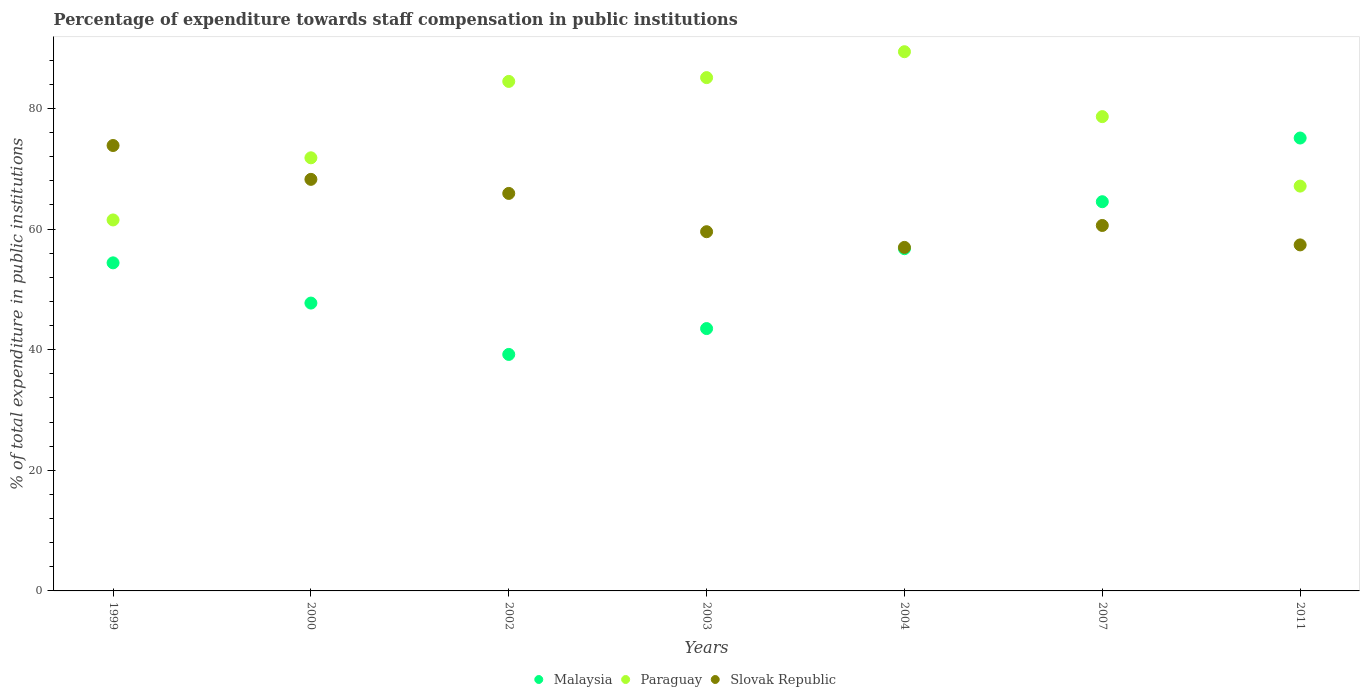How many different coloured dotlines are there?
Keep it short and to the point. 3. What is the percentage of expenditure towards staff compensation in Slovak Republic in 2004?
Ensure brevity in your answer.  56.97. Across all years, what is the maximum percentage of expenditure towards staff compensation in Malaysia?
Offer a very short reply. 75.1. Across all years, what is the minimum percentage of expenditure towards staff compensation in Slovak Republic?
Offer a very short reply. 56.97. In which year was the percentage of expenditure towards staff compensation in Slovak Republic maximum?
Give a very brief answer. 1999. What is the total percentage of expenditure towards staff compensation in Malaysia in the graph?
Provide a short and direct response. 381.25. What is the difference between the percentage of expenditure towards staff compensation in Malaysia in 2000 and that in 2007?
Your response must be concise. -16.81. What is the difference between the percentage of expenditure towards staff compensation in Paraguay in 2002 and the percentage of expenditure towards staff compensation in Malaysia in 2000?
Offer a terse response. 36.76. What is the average percentage of expenditure towards staff compensation in Paraguay per year?
Keep it short and to the point. 76.88. In the year 2007, what is the difference between the percentage of expenditure towards staff compensation in Slovak Republic and percentage of expenditure towards staff compensation in Paraguay?
Your answer should be compact. -18.05. In how many years, is the percentage of expenditure towards staff compensation in Malaysia greater than 12 %?
Ensure brevity in your answer.  7. What is the ratio of the percentage of expenditure towards staff compensation in Slovak Republic in 2000 to that in 2007?
Ensure brevity in your answer.  1.13. Is the percentage of expenditure towards staff compensation in Malaysia in 2000 less than that in 2003?
Make the answer very short. No. What is the difference between the highest and the second highest percentage of expenditure towards staff compensation in Malaysia?
Your response must be concise. 10.56. What is the difference between the highest and the lowest percentage of expenditure towards staff compensation in Slovak Republic?
Provide a succinct answer. 16.89. In how many years, is the percentage of expenditure towards staff compensation in Paraguay greater than the average percentage of expenditure towards staff compensation in Paraguay taken over all years?
Give a very brief answer. 4. Is the sum of the percentage of expenditure towards staff compensation in Malaysia in 2000 and 2002 greater than the maximum percentage of expenditure towards staff compensation in Slovak Republic across all years?
Ensure brevity in your answer.  Yes. Is the percentage of expenditure towards staff compensation in Slovak Republic strictly greater than the percentage of expenditure towards staff compensation in Paraguay over the years?
Keep it short and to the point. No. Is the percentage of expenditure towards staff compensation in Malaysia strictly less than the percentage of expenditure towards staff compensation in Paraguay over the years?
Keep it short and to the point. No. How many dotlines are there?
Your answer should be compact. 3. Are the values on the major ticks of Y-axis written in scientific E-notation?
Your answer should be compact. No. Where does the legend appear in the graph?
Ensure brevity in your answer.  Bottom center. How are the legend labels stacked?
Offer a terse response. Horizontal. What is the title of the graph?
Your answer should be compact. Percentage of expenditure towards staff compensation in public institutions. What is the label or title of the X-axis?
Your answer should be compact. Years. What is the label or title of the Y-axis?
Your response must be concise. % of total expenditure in public institutions. What is the % of total expenditure in public institutions of Malaysia in 1999?
Provide a succinct answer. 54.4. What is the % of total expenditure in public institutions in Paraguay in 1999?
Provide a short and direct response. 61.52. What is the % of total expenditure in public institutions of Slovak Republic in 1999?
Make the answer very short. 73.86. What is the % of total expenditure in public institutions in Malaysia in 2000?
Give a very brief answer. 47.73. What is the % of total expenditure in public institutions of Paraguay in 2000?
Give a very brief answer. 71.82. What is the % of total expenditure in public institutions of Slovak Republic in 2000?
Provide a succinct answer. 68.25. What is the % of total expenditure in public institutions in Malaysia in 2002?
Provide a short and direct response. 39.22. What is the % of total expenditure in public institutions in Paraguay in 2002?
Offer a very short reply. 84.49. What is the % of total expenditure in public institutions in Slovak Republic in 2002?
Give a very brief answer. 65.92. What is the % of total expenditure in public institutions in Malaysia in 2003?
Keep it short and to the point. 43.5. What is the % of total expenditure in public institutions of Paraguay in 2003?
Your answer should be very brief. 85.12. What is the % of total expenditure in public institutions in Slovak Republic in 2003?
Your response must be concise. 59.57. What is the % of total expenditure in public institutions of Malaysia in 2004?
Provide a succinct answer. 56.75. What is the % of total expenditure in public institutions in Paraguay in 2004?
Your answer should be very brief. 89.41. What is the % of total expenditure in public institutions of Slovak Republic in 2004?
Provide a succinct answer. 56.97. What is the % of total expenditure in public institutions in Malaysia in 2007?
Offer a very short reply. 64.54. What is the % of total expenditure in public institutions in Paraguay in 2007?
Give a very brief answer. 78.65. What is the % of total expenditure in public institutions of Slovak Republic in 2007?
Your response must be concise. 60.6. What is the % of total expenditure in public institutions in Malaysia in 2011?
Your answer should be very brief. 75.1. What is the % of total expenditure in public institutions in Paraguay in 2011?
Your response must be concise. 67.13. What is the % of total expenditure in public institutions of Slovak Republic in 2011?
Give a very brief answer. 57.38. Across all years, what is the maximum % of total expenditure in public institutions in Malaysia?
Offer a very short reply. 75.1. Across all years, what is the maximum % of total expenditure in public institutions in Paraguay?
Offer a terse response. 89.41. Across all years, what is the maximum % of total expenditure in public institutions of Slovak Republic?
Make the answer very short. 73.86. Across all years, what is the minimum % of total expenditure in public institutions in Malaysia?
Your answer should be compact. 39.22. Across all years, what is the minimum % of total expenditure in public institutions in Paraguay?
Offer a very short reply. 61.52. Across all years, what is the minimum % of total expenditure in public institutions in Slovak Republic?
Keep it short and to the point. 56.97. What is the total % of total expenditure in public institutions in Malaysia in the graph?
Your answer should be very brief. 381.25. What is the total % of total expenditure in public institutions in Paraguay in the graph?
Give a very brief answer. 538.14. What is the total % of total expenditure in public institutions of Slovak Republic in the graph?
Provide a succinct answer. 442.54. What is the difference between the % of total expenditure in public institutions of Malaysia in 1999 and that in 2000?
Provide a short and direct response. 6.67. What is the difference between the % of total expenditure in public institutions in Paraguay in 1999 and that in 2000?
Offer a terse response. -10.3. What is the difference between the % of total expenditure in public institutions in Slovak Republic in 1999 and that in 2000?
Your response must be concise. 5.61. What is the difference between the % of total expenditure in public institutions of Malaysia in 1999 and that in 2002?
Provide a short and direct response. 15.19. What is the difference between the % of total expenditure in public institutions of Paraguay in 1999 and that in 2002?
Make the answer very short. -22.97. What is the difference between the % of total expenditure in public institutions of Slovak Republic in 1999 and that in 2002?
Your answer should be very brief. 7.94. What is the difference between the % of total expenditure in public institutions of Malaysia in 1999 and that in 2003?
Offer a terse response. 10.9. What is the difference between the % of total expenditure in public institutions in Paraguay in 1999 and that in 2003?
Your response must be concise. -23.6. What is the difference between the % of total expenditure in public institutions in Slovak Republic in 1999 and that in 2003?
Ensure brevity in your answer.  14.29. What is the difference between the % of total expenditure in public institutions of Malaysia in 1999 and that in 2004?
Provide a succinct answer. -2.35. What is the difference between the % of total expenditure in public institutions in Paraguay in 1999 and that in 2004?
Your response must be concise. -27.9. What is the difference between the % of total expenditure in public institutions in Slovak Republic in 1999 and that in 2004?
Keep it short and to the point. 16.89. What is the difference between the % of total expenditure in public institutions in Malaysia in 1999 and that in 2007?
Your response must be concise. -10.14. What is the difference between the % of total expenditure in public institutions in Paraguay in 1999 and that in 2007?
Your answer should be very brief. -17.13. What is the difference between the % of total expenditure in public institutions of Slovak Republic in 1999 and that in 2007?
Provide a short and direct response. 13.26. What is the difference between the % of total expenditure in public institutions of Malaysia in 1999 and that in 2011?
Ensure brevity in your answer.  -20.7. What is the difference between the % of total expenditure in public institutions of Paraguay in 1999 and that in 2011?
Offer a very short reply. -5.61. What is the difference between the % of total expenditure in public institutions in Slovak Republic in 1999 and that in 2011?
Offer a terse response. 16.48. What is the difference between the % of total expenditure in public institutions in Malaysia in 2000 and that in 2002?
Your response must be concise. 8.52. What is the difference between the % of total expenditure in public institutions in Paraguay in 2000 and that in 2002?
Offer a terse response. -12.67. What is the difference between the % of total expenditure in public institutions in Slovak Republic in 2000 and that in 2002?
Offer a terse response. 2.33. What is the difference between the % of total expenditure in public institutions of Malaysia in 2000 and that in 2003?
Offer a terse response. 4.23. What is the difference between the % of total expenditure in public institutions in Paraguay in 2000 and that in 2003?
Provide a short and direct response. -13.3. What is the difference between the % of total expenditure in public institutions of Slovak Republic in 2000 and that in 2003?
Offer a very short reply. 8.68. What is the difference between the % of total expenditure in public institutions of Malaysia in 2000 and that in 2004?
Your response must be concise. -9.02. What is the difference between the % of total expenditure in public institutions in Paraguay in 2000 and that in 2004?
Give a very brief answer. -17.59. What is the difference between the % of total expenditure in public institutions in Slovak Republic in 2000 and that in 2004?
Give a very brief answer. 11.28. What is the difference between the % of total expenditure in public institutions of Malaysia in 2000 and that in 2007?
Provide a succinct answer. -16.81. What is the difference between the % of total expenditure in public institutions of Paraguay in 2000 and that in 2007?
Provide a short and direct response. -6.83. What is the difference between the % of total expenditure in public institutions of Slovak Republic in 2000 and that in 2007?
Your response must be concise. 7.65. What is the difference between the % of total expenditure in public institutions in Malaysia in 2000 and that in 2011?
Keep it short and to the point. -27.37. What is the difference between the % of total expenditure in public institutions in Paraguay in 2000 and that in 2011?
Your response must be concise. 4.69. What is the difference between the % of total expenditure in public institutions of Slovak Republic in 2000 and that in 2011?
Offer a terse response. 10.87. What is the difference between the % of total expenditure in public institutions in Malaysia in 2002 and that in 2003?
Keep it short and to the point. -4.29. What is the difference between the % of total expenditure in public institutions of Paraguay in 2002 and that in 2003?
Offer a terse response. -0.63. What is the difference between the % of total expenditure in public institutions of Slovak Republic in 2002 and that in 2003?
Give a very brief answer. 6.35. What is the difference between the % of total expenditure in public institutions of Malaysia in 2002 and that in 2004?
Provide a succinct answer. -17.53. What is the difference between the % of total expenditure in public institutions in Paraguay in 2002 and that in 2004?
Provide a short and direct response. -4.93. What is the difference between the % of total expenditure in public institutions in Slovak Republic in 2002 and that in 2004?
Provide a short and direct response. 8.95. What is the difference between the % of total expenditure in public institutions of Malaysia in 2002 and that in 2007?
Your answer should be compact. -25.32. What is the difference between the % of total expenditure in public institutions in Paraguay in 2002 and that in 2007?
Ensure brevity in your answer.  5.84. What is the difference between the % of total expenditure in public institutions of Slovak Republic in 2002 and that in 2007?
Your response must be concise. 5.31. What is the difference between the % of total expenditure in public institutions of Malaysia in 2002 and that in 2011?
Offer a terse response. -35.89. What is the difference between the % of total expenditure in public institutions of Paraguay in 2002 and that in 2011?
Your answer should be compact. 17.36. What is the difference between the % of total expenditure in public institutions of Slovak Republic in 2002 and that in 2011?
Ensure brevity in your answer.  8.54. What is the difference between the % of total expenditure in public institutions of Malaysia in 2003 and that in 2004?
Provide a succinct answer. -13.25. What is the difference between the % of total expenditure in public institutions of Paraguay in 2003 and that in 2004?
Keep it short and to the point. -4.3. What is the difference between the % of total expenditure in public institutions of Slovak Republic in 2003 and that in 2004?
Give a very brief answer. 2.6. What is the difference between the % of total expenditure in public institutions of Malaysia in 2003 and that in 2007?
Make the answer very short. -21.04. What is the difference between the % of total expenditure in public institutions of Paraguay in 2003 and that in 2007?
Your answer should be very brief. 6.47. What is the difference between the % of total expenditure in public institutions of Slovak Republic in 2003 and that in 2007?
Your response must be concise. -1.03. What is the difference between the % of total expenditure in public institutions in Malaysia in 2003 and that in 2011?
Provide a short and direct response. -31.6. What is the difference between the % of total expenditure in public institutions in Paraguay in 2003 and that in 2011?
Your answer should be compact. 17.99. What is the difference between the % of total expenditure in public institutions of Slovak Republic in 2003 and that in 2011?
Provide a short and direct response. 2.19. What is the difference between the % of total expenditure in public institutions of Malaysia in 2004 and that in 2007?
Your response must be concise. -7.79. What is the difference between the % of total expenditure in public institutions in Paraguay in 2004 and that in 2007?
Ensure brevity in your answer.  10.76. What is the difference between the % of total expenditure in public institutions in Slovak Republic in 2004 and that in 2007?
Your answer should be very brief. -3.63. What is the difference between the % of total expenditure in public institutions of Malaysia in 2004 and that in 2011?
Your response must be concise. -18.35. What is the difference between the % of total expenditure in public institutions in Paraguay in 2004 and that in 2011?
Provide a succinct answer. 22.29. What is the difference between the % of total expenditure in public institutions in Slovak Republic in 2004 and that in 2011?
Ensure brevity in your answer.  -0.41. What is the difference between the % of total expenditure in public institutions in Malaysia in 2007 and that in 2011?
Give a very brief answer. -10.56. What is the difference between the % of total expenditure in public institutions of Paraguay in 2007 and that in 2011?
Give a very brief answer. 11.52. What is the difference between the % of total expenditure in public institutions of Slovak Republic in 2007 and that in 2011?
Provide a succinct answer. 3.22. What is the difference between the % of total expenditure in public institutions in Malaysia in 1999 and the % of total expenditure in public institutions in Paraguay in 2000?
Provide a short and direct response. -17.42. What is the difference between the % of total expenditure in public institutions in Malaysia in 1999 and the % of total expenditure in public institutions in Slovak Republic in 2000?
Keep it short and to the point. -13.85. What is the difference between the % of total expenditure in public institutions in Paraguay in 1999 and the % of total expenditure in public institutions in Slovak Republic in 2000?
Give a very brief answer. -6.73. What is the difference between the % of total expenditure in public institutions of Malaysia in 1999 and the % of total expenditure in public institutions of Paraguay in 2002?
Your answer should be very brief. -30.09. What is the difference between the % of total expenditure in public institutions of Malaysia in 1999 and the % of total expenditure in public institutions of Slovak Republic in 2002?
Provide a short and direct response. -11.51. What is the difference between the % of total expenditure in public institutions of Paraguay in 1999 and the % of total expenditure in public institutions of Slovak Republic in 2002?
Your response must be concise. -4.4. What is the difference between the % of total expenditure in public institutions of Malaysia in 1999 and the % of total expenditure in public institutions of Paraguay in 2003?
Provide a succinct answer. -30.72. What is the difference between the % of total expenditure in public institutions in Malaysia in 1999 and the % of total expenditure in public institutions in Slovak Republic in 2003?
Offer a terse response. -5.16. What is the difference between the % of total expenditure in public institutions of Paraguay in 1999 and the % of total expenditure in public institutions of Slovak Republic in 2003?
Give a very brief answer. 1.95. What is the difference between the % of total expenditure in public institutions in Malaysia in 1999 and the % of total expenditure in public institutions in Paraguay in 2004?
Give a very brief answer. -35.01. What is the difference between the % of total expenditure in public institutions in Malaysia in 1999 and the % of total expenditure in public institutions in Slovak Republic in 2004?
Give a very brief answer. -2.56. What is the difference between the % of total expenditure in public institutions of Paraguay in 1999 and the % of total expenditure in public institutions of Slovak Republic in 2004?
Provide a succinct answer. 4.55. What is the difference between the % of total expenditure in public institutions in Malaysia in 1999 and the % of total expenditure in public institutions in Paraguay in 2007?
Keep it short and to the point. -24.25. What is the difference between the % of total expenditure in public institutions in Malaysia in 1999 and the % of total expenditure in public institutions in Slovak Republic in 2007?
Keep it short and to the point. -6.2. What is the difference between the % of total expenditure in public institutions in Malaysia in 1999 and the % of total expenditure in public institutions in Paraguay in 2011?
Offer a terse response. -12.73. What is the difference between the % of total expenditure in public institutions of Malaysia in 1999 and the % of total expenditure in public institutions of Slovak Republic in 2011?
Ensure brevity in your answer.  -2.98. What is the difference between the % of total expenditure in public institutions in Paraguay in 1999 and the % of total expenditure in public institutions in Slovak Republic in 2011?
Offer a terse response. 4.14. What is the difference between the % of total expenditure in public institutions in Malaysia in 2000 and the % of total expenditure in public institutions in Paraguay in 2002?
Offer a very short reply. -36.76. What is the difference between the % of total expenditure in public institutions in Malaysia in 2000 and the % of total expenditure in public institutions in Slovak Republic in 2002?
Offer a terse response. -18.18. What is the difference between the % of total expenditure in public institutions in Paraguay in 2000 and the % of total expenditure in public institutions in Slovak Republic in 2002?
Your response must be concise. 5.91. What is the difference between the % of total expenditure in public institutions in Malaysia in 2000 and the % of total expenditure in public institutions in Paraguay in 2003?
Ensure brevity in your answer.  -37.39. What is the difference between the % of total expenditure in public institutions of Malaysia in 2000 and the % of total expenditure in public institutions of Slovak Republic in 2003?
Offer a terse response. -11.83. What is the difference between the % of total expenditure in public institutions in Paraguay in 2000 and the % of total expenditure in public institutions in Slovak Republic in 2003?
Ensure brevity in your answer.  12.26. What is the difference between the % of total expenditure in public institutions of Malaysia in 2000 and the % of total expenditure in public institutions of Paraguay in 2004?
Ensure brevity in your answer.  -41.68. What is the difference between the % of total expenditure in public institutions of Malaysia in 2000 and the % of total expenditure in public institutions of Slovak Republic in 2004?
Keep it short and to the point. -9.23. What is the difference between the % of total expenditure in public institutions in Paraguay in 2000 and the % of total expenditure in public institutions in Slovak Republic in 2004?
Offer a terse response. 14.86. What is the difference between the % of total expenditure in public institutions of Malaysia in 2000 and the % of total expenditure in public institutions of Paraguay in 2007?
Give a very brief answer. -30.92. What is the difference between the % of total expenditure in public institutions of Malaysia in 2000 and the % of total expenditure in public institutions of Slovak Republic in 2007?
Give a very brief answer. -12.87. What is the difference between the % of total expenditure in public institutions of Paraguay in 2000 and the % of total expenditure in public institutions of Slovak Republic in 2007?
Your response must be concise. 11.22. What is the difference between the % of total expenditure in public institutions in Malaysia in 2000 and the % of total expenditure in public institutions in Paraguay in 2011?
Give a very brief answer. -19.4. What is the difference between the % of total expenditure in public institutions in Malaysia in 2000 and the % of total expenditure in public institutions in Slovak Republic in 2011?
Offer a terse response. -9.65. What is the difference between the % of total expenditure in public institutions of Paraguay in 2000 and the % of total expenditure in public institutions of Slovak Republic in 2011?
Give a very brief answer. 14.44. What is the difference between the % of total expenditure in public institutions in Malaysia in 2002 and the % of total expenditure in public institutions in Paraguay in 2003?
Your answer should be compact. -45.9. What is the difference between the % of total expenditure in public institutions of Malaysia in 2002 and the % of total expenditure in public institutions of Slovak Republic in 2003?
Keep it short and to the point. -20.35. What is the difference between the % of total expenditure in public institutions in Paraguay in 2002 and the % of total expenditure in public institutions in Slovak Republic in 2003?
Provide a short and direct response. 24.92. What is the difference between the % of total expenditure in public institutions of Malaysia in 2002 and the % of total expenditure in public institutions of Paraguay in 2004?
Your answer should be compact. -50.2. What is the difference between the % of total expenditure in public institutions of Malaysia in 2002 and the % of total expenditure in public institutions of Slovak Republic in 2004?
Keep it short and to the point. -17.75. What is the difference between the % of total expenditure in public institutions of Paraguay in 2002 and the % of total expenditure in public institutions of Slovak Republic in 2004?
Give a very brief answer. 27.52. What is the difference between the % of total expenditure in public institutions in Malaysia in 2002 and the % of total expenditure in public institutions in Paraguay in 2007?
Make the answer very short. -39.44. What is the difference between the % of total expenditure in public institutions in Malaysia in 2002 and the % of total expenditure in public institutions in Slovak Republic in 2007?
Give a very brief answer. -21.38. What is the difference between the % of total expenditure in public institutions of Paraguay in 2002 and the % of total expenditure in public institutions of Slovak Republic in 2007?
Provide a succinct answer. 23.89. What is the difference between the % of total expenditure in public institutions of Malaysia in 2002 and the % of total expenditure in public institutions of Paraguay in 2011?
Offer a terse response. -27.91. What is the difference between the % of total expenditure in public institutions in Malaysia in 2002 and the % of total expenditure in public institutions in Slovak Republic in 2011?
Ensure brevity in your answer.  -18.16. What is the difference between the % of total expenditure in public institutions of Paraguay in 2002 and the % of total expenditure in public institutions of Slovak Republic in 2011?
Keep it short and to the point. 27.11. What is the difference between the % of total expenditure in public institutions in Malaysia in 2003 and the % of total expenditure in public institutions in Paraguay in 2004?
Your answer should be compact. -45.91. What is the difference between the % of total expenditure in public institutions of Malaysia in 2003 and the % of total expenditure in public institutions of Slovak Republic in 2004?
Offer a very short reply. -13.46. What is the difference between the % of total expenditure in public institutions of Paraguay in 2003 and the % of total expenditure in public institutions of Slovak Republic in 2004?
Your answer should be very brief. 28.15. What is the difference between the % of total expenditure in public institutions of Malaysia in 2003 and the % of total expenditure in public institutions of Paraguay in 2007?
Keep it short and to the point. -35.15. What is the difference between the % of total expenditure in public institutions in Malaysia in 2003 and the % of total expenditure in public institutions in Slovak Republic in 2007?
Give a very brief answer. -17.1. What is the difference between the % of total expenditure in public institutions of Paraguay in 2003 and the % of total expenditure in public institutions of Slovak Republic in 2007?
Provide a succinct answer. 24.52. What is the difference between the % of total expenditure in public institutions of Malaysia in 2003 and the % of total expenditure in public institutions of Paraguay in 2011?
Your answer should be very brief. -23.62. What is the difference between the % of total expenditure in public institutions of Malaysia in 2003 and the % of total expenditure in public institutions of Slovak Republic in 2011?
Make the answer very short. -13.88. What is the difference between the % of total expenditure in public institutions of Paraguay in 2003 and the % of total expenditure in public institutions of Slovak Republic in 2011?
Your answer should be very brief. 27.74. What is the difference between the % of total expenditure in public institutions in Malaysia in 2004 and the % of total expenditure in public institutions in Paraguay in 2007?
Provide a succinct answer. -21.9. What is the difference between the % of total expenditure in public institutions in Malaysia in 2004 and the % of total expenditure in public institutions in Slovak Republic in 2007?
Your response must be concise. -3.85. What is the difference between the % of total expenditure in public institutions of Paraguay in 2004 and the % of total expenditure in public institutions of Slovak Republic in 2007?
Offer a very short reply. 28.81. What is the difference between the % of total expenditure in public institutions of Malaysia in 2004 and the % of total expenditure in public institutions of Paraguay in 2011?
Ensure brevity in your answer.  -10.38. What is the difference between the % of total expenditure in public institutions in Malaysia in 2004 and the % of total expenditure in public institutions in Slovak Republic in 2011?
Provide a succinct answer. -0.63. What is the difference between the % of total expenditure in public institutions in Paraguay in 2004 and the % of total expenditure in public institutions in Slovak Republic in 2011?
Provide a short and direct response. 32.03. What is the difference between the % of total expenditure in public institutions in Malaysia in 2007 and the % of total expenditure in public institutions in Paraguay in 2011?
Your answer should be compact. -2.59. What is the difference between the % of total expenditure in public institutions in Malaysia in 2007 and the % of total expenditure in public institutions in Slovak Republic in 2011?
Provide a succinct answer. 7.16. What is the difference between the % of total expenditure in public institutions in Paraguay in 2007 and the % of total expenditure in public institutions in Slovak Republic in 2011?
Give a very brief answer. 21.27. What is the average % of total expenditure in public institutions in Malaysia per year?
Your answer should be compact. 54.46. What is the average % of total expenditure in public institutions in Paraguay per year?
Offer a very short reply. 76.88. What is the average % of total expenditure in public institutions in Slovak Republic per year?
Your answer should be very brief. 63.22. In the year 1999, what is the difference between the % of total expenditure in public institutions in Malaysia and % of total expenditure in public institutions in Paraguay?
Your answer should be very brief. -7.11. In the year 1999, what is the difference between the % of total expenditure in public institutions in Malaysia and % of total expenditure in public institutions in Slovak Republic?
Make the answer very short. -19.46. In the year 1999, what is the difference between the % of total expenditure in public institutions in Paraguay and % of total expenditure in public institutions in Slovak Republic?
Make the answer very short. -12.34. In the year 2000, what is the difference between the % of total expenditure in public institutions in Malaysia and % of total expenditure in public institutions in Paraguay?
Give a very brief answer. -24.09. In the year 2000, what is the difference between the % of total expenditure in public institutions of Malaysia and % of total expenditure in public institutions of Slovak Republic?
Provide a short and direct response. -20.52. In the year 2000, what is the difference between the % of total expenditure in public institutions in Paraguay and % of total expenditure in public institutions in Slovak Republic?
Provide a short and direct response. 3.57. In the year 2002, what is the difference between the % of total expenditure in public institutions of Malaysia and % of total expenditure in public institutions of Paraguay?
Offer a very short reply. -45.27. In the year 2002, what is the difference between the % of total expenditure in public institutions of Malaysia and % of total expenditure in public institutions of Slovak Republic?
Make the answer very short. -26.7. In the year 2002, what is the difference between the % of total expenditure in public institutions of Paraguay and % of total expenditure in public institutions of Slovak Republic?
Offer a terse response. 18.57. In the year 2003, what is the difference between the % of total expenditure in public institutions in Malaysia and % of total expenditure in public institutions in Paraguay?
Provide a short and direct response. -41.61. In the year 2003, what is the difference between the % of total expenditure in public institutions in Malaysia and % of total expenditure in public institutions in Slovak Republic?
Your response must be concise. -16.06. In the year 2003, what is the difference between the % of total expenditure in public institutions in Paraguay and % of total expenditure in public institutions in Slovak Republic?
Ensure brevity in your answer.  25.55. In the year 2004, what is the difference between the % of total expenditure in public institutions of Malaysia and % of total expenditure in public institutions of Paraguay?
Keep it short and to the point. -32.66. In the year 2004, what is the difference between the % of total expenditure in public institutions in Malaysia and % of total expenditure in public institutions in Slovak Republic?
Ensure brevity in your answer.  -0.21. In the year 2004, what is the difference between the % of total expenditure in public institutions in Paraguay and % of total expenditure in public institutions in Slovak Republic?
Give a very brief answer. 32.45. In the year 2007, what is the difference between the % of total expenditure in public institutions of Malaysia and % of total expenditure in public institutions of Paraguay?
Give a very brief answer. -14.11. In the year 2007, what is the difference between the % of total expenditure in public institutions of Malaysia and % of total expenditure in public institutions of Slovak Republic?
Ensure brevity in your answer.  3.94. In the year 2007, what is the difference between the % of total expenditure in public institutions in Paraguay and % of total expenditure in public institutions in Slovak Republic?
Keep it short and to the point. 18.05. In the year 2011, what is the difference between the % of total expenditure in public institutions in Malaysia and % of total expenditure in public institutions in Paraguay?
Give a very brief answer. 7.97. In the year 2011, what is the difference between the % of total expenditure in public institutions in Malaysia and % of total expenditure in public institutions in Slovak Republic?
Ensure brevity in your answer.  17.72. In the year 2011, what is the difference between the % of total expenditure in public institutions of Paraguay and % of total expenditure in public institutions of Slovak Republic?
Provide a short and direct response. 9.75. What is the ratio of the % of total expenditure in public institutions in Malaysia in 1999 to that in 2000?
Offer a very short reply. 1.14. What is the ratio of the % of total expenditure in public institutions in Paraguay in 1999 to that in 2000?
Offer a terse response. 0.86. What is the ratio of the % of total expenditure in public institutions in Slovak Republic in 1999 to that in 2000?
Your answer should be very brief. 1.08. What is the ratio of the % of total expenditure in public institutions in Malaysia in 1999 to that in 2002?
Your answer should be compact. 1.39. What is the ratio of the % of total expenditure in public institutions in Paraguay in 1999 to that in 2002?
Provide a short and direct response. 0.73. What is the ratio of the % of total expenditure in public institutions of Slovak Republic in 1999 to that in 2002?
Offer a terse response. 1.12. What is the ratio of the % of total expenditure in public institutions of Malaysia in 1999 to that in 2003?
Provide a short and direct response. 1.25. What is the ratio of the % of total expenditure in public institutions in Paraguay in 1999 to that in 2003?
Your response must be concise. 0.72. What is the ratio of the % of total expenditure in public institutions of Slovak Republic in 1999 to that in 2003?
Your answer should be compact. 1.24. What is the ratio of the % of total expenditure in public institutions in Malaysia in 1999 to that in 2004?
Ensure brevity in your answer.  0.96. What is the ratio of the % of total expenditure in public institutions of Paraguay in 1999 to that in 2004?
Keep it short and to the point. 0.69. What is the ratio of the % of total expenditure in public institutions of Slovak Republic in 1999 to that in 2004?
Keep it short and to the point. 1.3. What is the ratio of the % of total expenditure in public institutions in Malaysia in 1999 to that in 2007?
Your answer should be compact. 0.84. What is the ratio of the % of total expenditure in public institutions of Paraguay in 1999 to that in 2007?
Provide a succinct answer. 0.78. What is the ratio of the % of total expenditure in public institutions in Slovak Republic in 1999 to that in 2007?
Your answer should be very brief. 1.22. What is the ratio of the % of total expenditure in public institutions of Malaysia in 1999 to that in 2011?
Provide a succinct answer. 0.72. What is the ratio of the % of total expenditure in public institutions in Paraguay in 1999 to that in 2011?
Offer a terse response. 0.92. What is the ratio of the % of total expenditure in public institutions of Slovak Republic in 1999 to that in 2011?
Provide a short and direct response. 1.29. What is the ratio of the % of total expenditure in public institutions of Malaysia in 2000 to that in 2002?
Ensure brevity in your answer.  1.22. What is the ratio of the % of total expenditure in public institutions in Paraguay in 2000 to that in 2002?
Provide a short and direct response. 0.85. What is the ratio of the % of total expenditure in public institutions in Slovak Republic in 2000 to that in 2002?
Offer a very short reply. 1.04. What is the ratio of the % of total expenditure in public institutions in Malaysia in 2000 to that in 2003?
Give a very brief answer. 1.1. What is the ratio of the % of total expenditure in public institutions in Paraguay in 2000 to that in 2003?
Your response must be concise. 0.84. What is the ratio of the % of total expenditure in public institutions of Slovak Republic in 2000 to that in 2003?
Offer a very short reply. 1.15. What is the ratio of the % of total expenditure in public institutions of Malaysia in 2000 to that in 2004?
Provide a short and direct response. 0.84. What is the ratio of the % of total expenditure in public institutions of Paraguay in 2000 to that in 2004?
Give a very brief answer. 0.8. What is the ratio of the % of total expenditure in public institutions in Slovak Republic in 2000 to that in 2004?
Provide a succinct answer. 1.2. What is the ratio of the % of total expenditure in public institutions of Malaysia in 2000 to that in 2007?
Give a very brief answer. 0.74. What is the ratio of the % of total expenditure in public institutions of Paraguay in 2000 to that in 2007?
Offer a terse response. 0.91. What is the ratio of the % of total expenditure in public institutions of Slovak Republic in 2000 to that in 2007?
Your response must be concise. 1.13. What is the ratio of the % of total expenditure in public institutions in Malaysia in 2000 to that in 2011?
Provide a succinct answer. 0.64. What is the ratio of the % of total expenditure in public institutions in Paraguay in 2000 to that in 2011?
Make the answer very short. 1.07. What is the ratio of the % of total expenditure in public institutions in Slovak Republic in 2000 to that in 2011?
Provide a succinct answer. 1.19. What is the ratio of the % of total expenditure in public institutions in Malaysia in 2002 to that in 2003?
Your answer should be very brief. 0.9. What is the ratio of the % of total expenditure in public institutions in Paraguay in 2002 to that in 2003?
Offer a very short reply. 0.99. What is the ratio of the % of total expenditure in public institutions of Slovak Republic in 2002 to that in 2003?
Make the answer very short. 1.11. What is the ratio of the % of total expenditure in public institutions of Malaysia in 2002 to that in 2004?
Give a very brief answer. 0.69. What is the ratio of the % of total expenditure in public institutions of Paraguay in 2002 to that in 2004?
Keep it short and to the point. 0.94. What is the ratio of the % of total expenditure in public institutions in Slovak Republic in 2002 to that in 2004?
Offer a very short reply. 1.16. What is the ratio of the % of total expenditure in public institutions of Malaysia in 2002 to that in 2007?
Make the answer very short. 0.61. What is the ratio of the % of total expenditure in public institutions of Paraguay in 2002 to that in 2007?
Your response must be concise. 1.07. What is the ratio of the % of total expenditure in public institutions in Slovak Republic in 2002 to that in 2007?
Your answer should be compact. 1.09. What is the ratio of the % of total expenditure in public institutions of Malaysia in 2002 to that in 2011?
Give a very brief answer. 0.52. What is the ratio of the % of total expenditure in public institutions of Paraguay in 2002 to that in 2011?
Keep it short and to the point. 1.26. What is the ratio of the % of total expenditure in public institutions in Slovak Republic in 2002 to that in 2011?
Give a very brief answer. 1.15. What is the ratio of the % of total expenditure in public institutions in Malaysia in 2003 to that in 2004?
Your answer should be compact. 0.77. What is the ratio of the % of total expenditure in public institutions in Slovak Republic in 2003 to that in 2004?
Offer a very short reply. 1.05. What is the ratio of the % of total expenditure in public institutions of Malaysia in 2003 to that in 2007?
Your answer should be compact. 0.67. What is the ratio of the % of total expenditure in public institutions of Paraguay in 2003 to that in 2007?
Make the answer very short. 1.08. What is the ratio of the % of total expenditure in public institutions in Slovak Republic in 2003 to that in 2007?
Make the answer very short. 0.98. What is the ratio of the % of total expenditure in public institutions of Malaysia in 2003 to that in 2011?
Keep it short and to the point. 0.58. What is the ratio of the % of total expenditure in public institutions of Paraguay in 2003 to that in 2011?
Give a very brief answer. 1.27. What is the ratio of the % of total expenditure in public institutions in Slovak Republic in 2003 to that in 2011?
Make the answer very short. 1.04. What is the ratio of the % of total expenditure in public institutions of Malaysia in 2004 to that in 2007?
Your answer should be very brief. 0.88. What is the ratio of the % of total expenditure in public institutions in Paraguay in 2004 to that in 2007?
Provide a short and direct response. 1.14. What is the ratio of the % of total expenditure in public institutions of Malaysia in 2004 to that in 2011?
Your response must be concise. 0.76. What is the ratio of the % of total expenditure in public institutions in Paraguay in 2004 to that in 2011?
Your answer should be compact. 1.33. What is the ratio of the % of total expenditure in public institutions of Slovak Republic in 2004 to that in 2011?
Make the answer very short. 0.99. What is the ratio of the % of total expenditure in public institutions of Malaysia in 2007 to that in 2011?
Offer a very short reply. 0.86. What is the ratio of the % of total expenditure in public institutions of Paraguay in 2007 to that in 2011?
Your answer should be compact. 1.17. What is the ratio of the % of total expenditure in public institutions in Slovak Republic in 2007 to that in 2011?
Ensure brevity in your answer.  1.06. What is the difference between the highest and the second highest % of total expenditure in public institutions of Malaysia?
Offer a terse response. 10.56. What is the difference between the highest and the second highest % of total expenditure in public institutions in Paraguay?
Your response must be concise. 4.3. What is the difference between the highest and the second highest % of total expenditure in public institutions of Slovak Republic?
Offer a very short reply. 5.61. What is the difference between the highest and the lowest % of total expenditure in public institutions in Malaysia?
Your response must be concise. 35.89. What is the difference between the highest and the lowest % of total expenditure in public institutions in Paraguay?
Ensure brevity in your answer.  27.9. What is the difference between the highest and the lowest % of total expenditure in public institutions in Slovak Republic?
Provide a succinct answer. 16.89. 